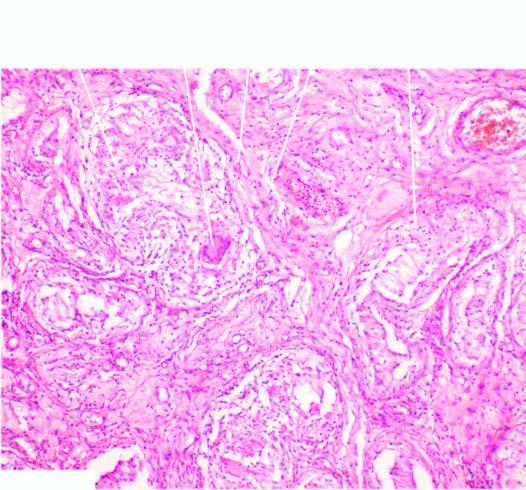what contains several epithelioid cell granulomas with central areas of caseation necrosis?
Answer the question using a single word or phrase. Interstitium 